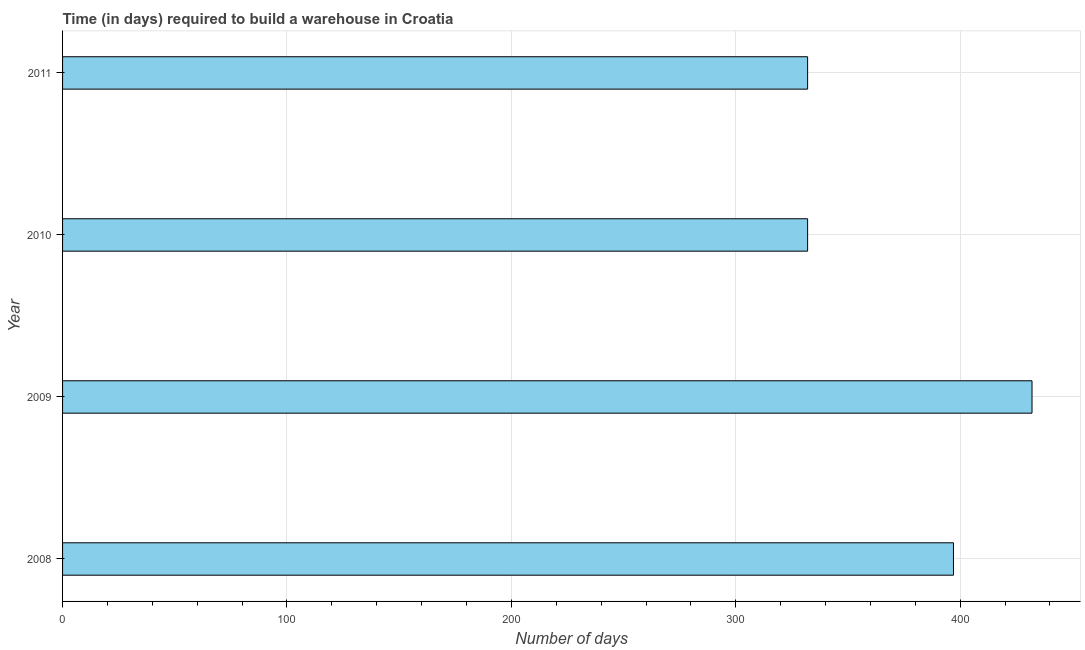Does the graph contain any zero values?
Your response must be concise. No. Does the graph contain grids?
Your response must be concise. Yes. What is the title of the graph?
Keep it short and to the point. Time (in days) required to build a warehouse in Croatia. What is the label or title of the X-axis?
Offer a terse response. Number of days. What is the label or title of the Y-axis?
Your answer should be very brief. Year. What is the time required to build a warehouse in 2011?
Offer a terse response. 332. Across all years, what is the maximum time required to build a warehouse?
Offer a very short reply. 432. Across all years, what is the minimum time required to build a warehouse?
Your answer should be compact. 332. In which year was the time required to build a warehouse maximum?
Provide a short and direct response. 2009. What is the sum of the time required to build a warehouse?
Give a very brief answer. 1493. What is the difference between the time required to build a warehouse in 2009 and 2010?
Make the answer very short. 100. What is the average time required to build a warehouse per year?
Your answer should be very brief. 373. What is the median time required to build a warehouse?
Give a very brief answer. 364.5. What is the ratio of the time required to build a warehouse in 2008 to that in 2010?
Make the answer very short. 1.2. Is the time required to build a warehouse in 2009 less than that in 2010?
Offer a very short reply. No. Is the difference between the time required to build a warehouse in 2010 and 2011 greater than the difference between any two years?
Your response must be concise. No. What is the difference between the highest and the second highest time required to build a warehouse?
Make the answer very short. 35. How many years are there in the graph?
Your answer should be compact. 4. What is the difference between two consecutive major ticks on the X-axis?
Give a very brief answer. 100. What is the Number of days of 2008?
Ensure brevity in your answer.  397. What is the Number of days in 2009?
Give a very brief answer. 432. What is the Number of days in 2010?
Your answer should be compact. 332. What is the Number of days of 2011?
Ensure brevity in your answer.  332. What is the difference between the Number of days in 2008 and 2009?
Give a very brief answer. -35. What is the difference between the Number of days in 2008 and 2011?
Your response must be concise. 65. What is the difference between the Number of days in 2009 and 2010?
Provide a short and direct response. 100. What is the difference between the Number of days in 2009 and 2011?
Give a very brief answer. 100. What is the ratio of the Number of days in 2008 to that in 2009?
Your answer should be compact. 0.92. What is the ratio of the Number of days in 2008 to that in 2010?
Offer a very short reply. 1.2. What is the ratio of the Number of days in 2008 to that in 2011?
Provide a short and direct response. 1.2. What is the ratio of the Number of days in 2009 to that in 2010?
Ensure brevity in your answer.  1.3. What is the ratio of the Number of days in 2009 to that in 2011?
Keep it short and to the point. 1.3. 